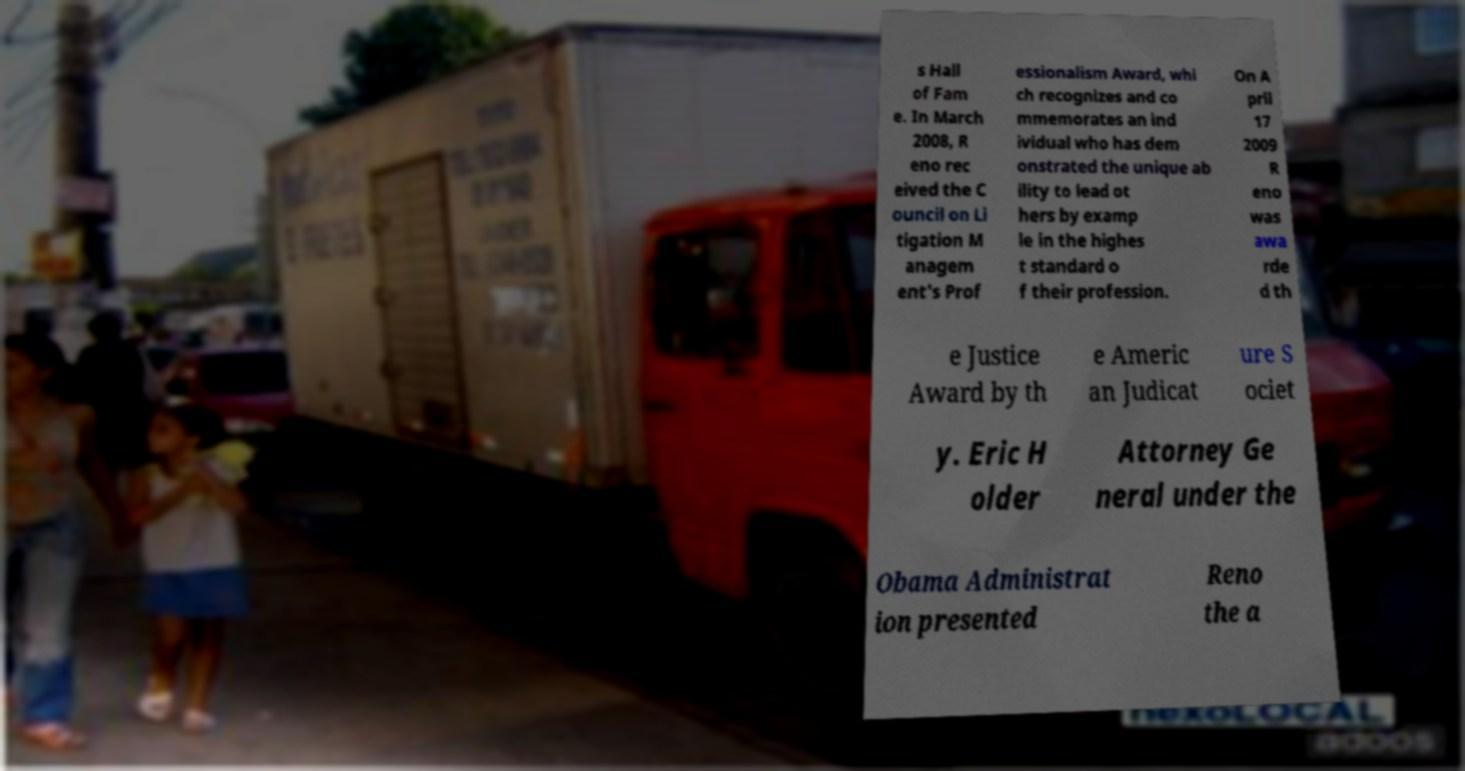What details can you provide about the truck visible in the image? The truck in the image is a red vehicle with a white cargo compartment. You cannot discern the exact make or model due to the angle and the quality of the image, but it is clear that it's a medium-sized truck typically used for deliveries within cities. The side of the cargo compartment is featureless, so there is no visible branding or additional information that might indicate ownership or the type of goods it carries. 